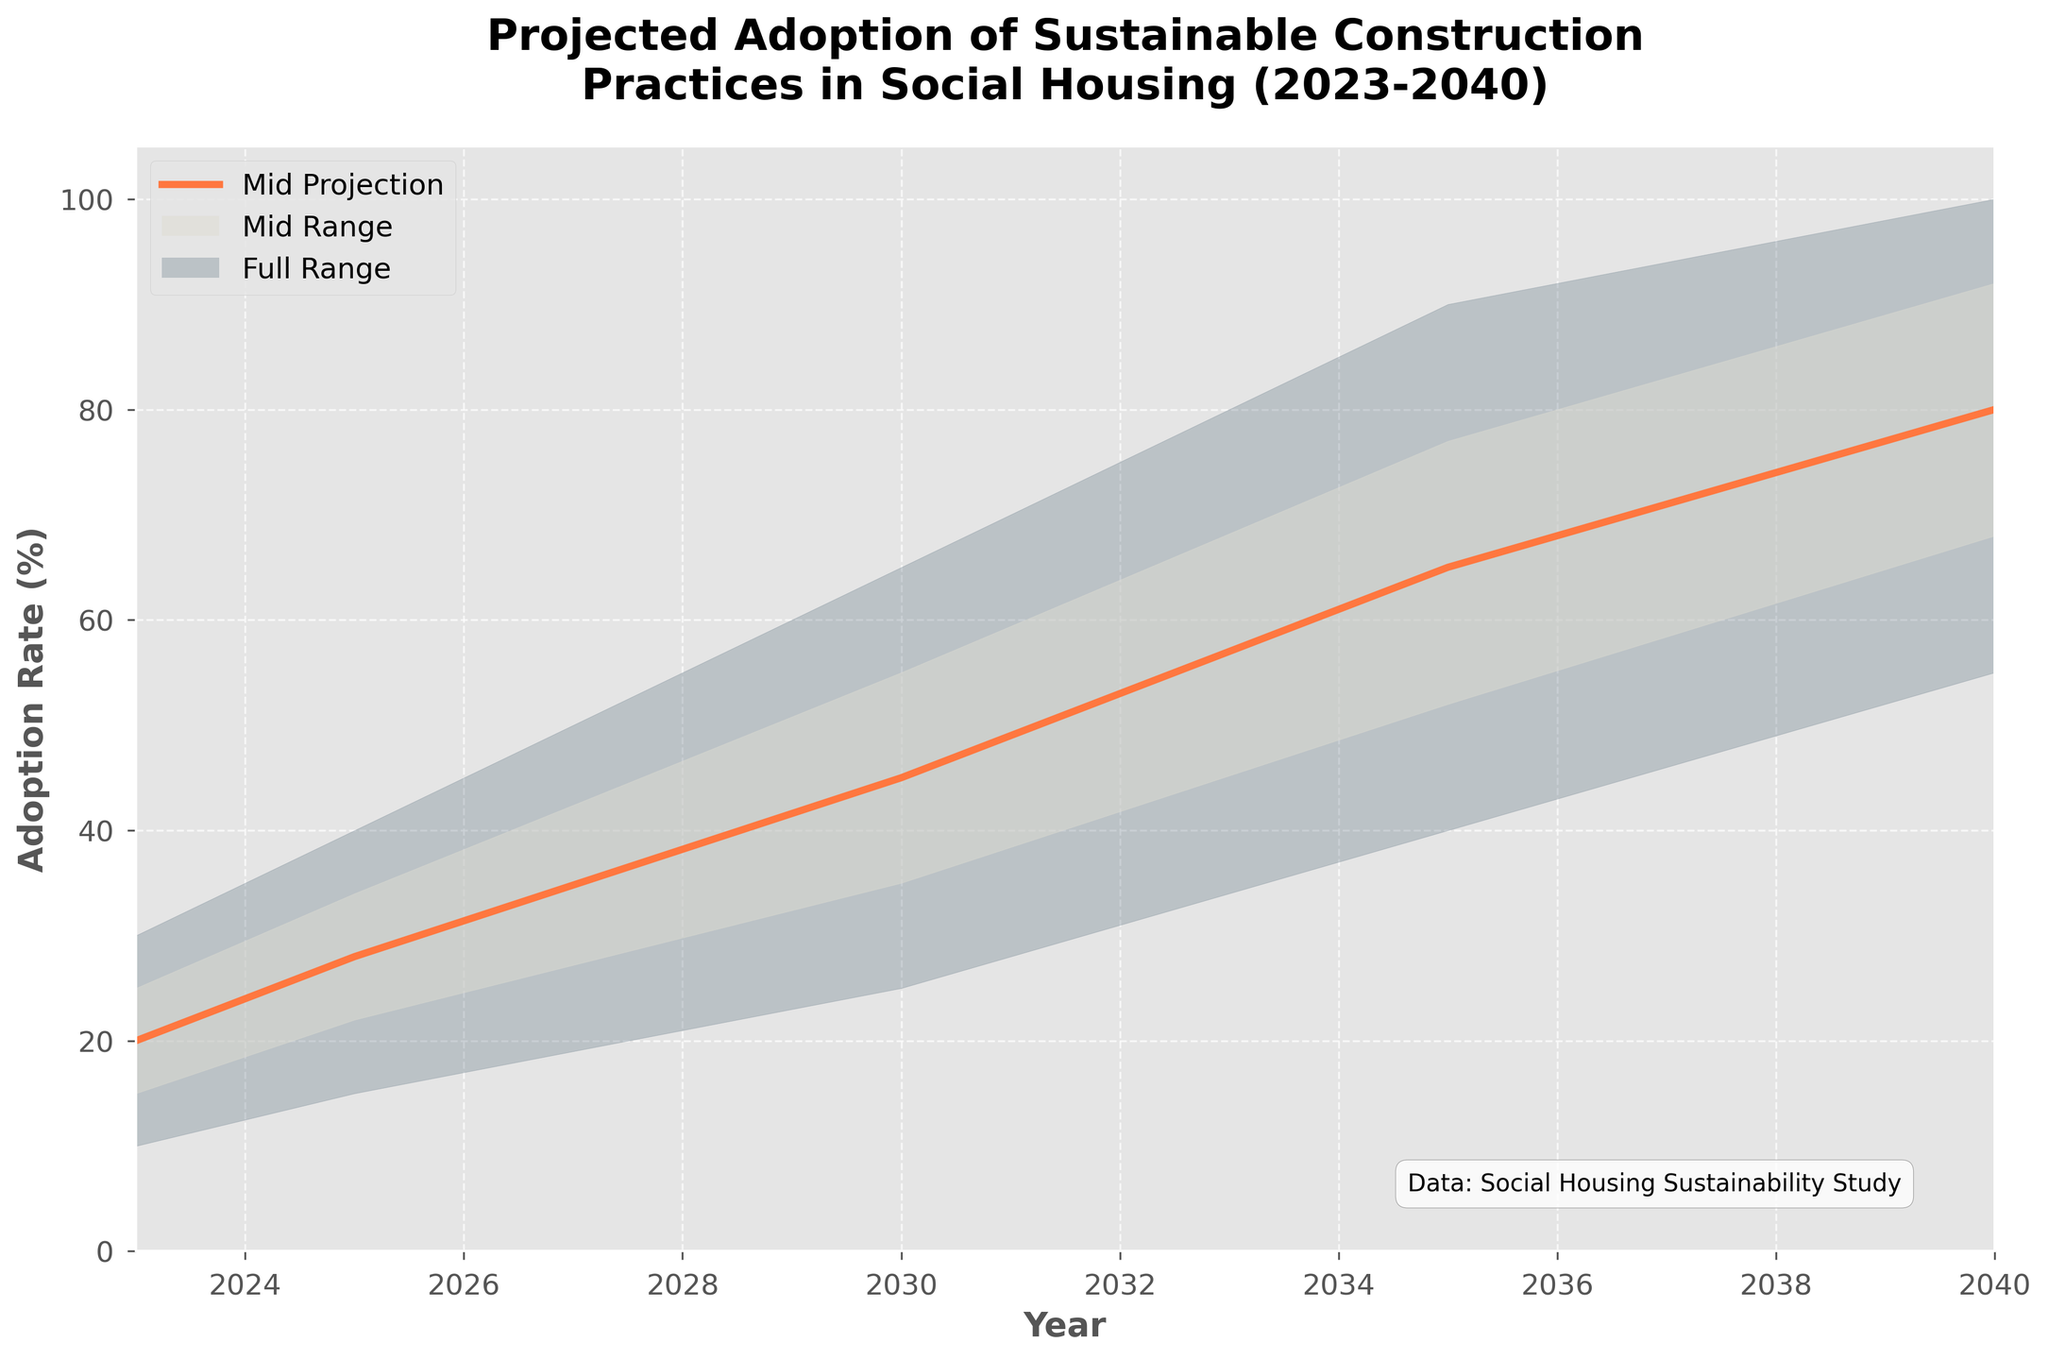What's the title of the chart? The title of the chart is located at the top and in bold. It reads, "Projected Adoption of Sustainable Construction Practices in Social Housing (2023-2040)."
Answer: Projected Adoption of Sustainable Construction Practices in Social Housing (2023-2040) What does the "Mid Projection" line represent? The "Mid Projection" line is the thick line on the chart that represents the midpoint of the projected adoption rates. It's plotted across the years and shows the expected rate of adoption under normal circumstances.
Answer: The midpoint of projected adoption rates What range of adoption rates is projected for the year 2030? To find the range of adoption rates for 2030, look at the filled areas in the chart for that year. The low and high values for 2030 are 25% and 65%, respectively, indicating that the adoption rate could be anywhere within this range.
Answer: 25% to 65% Which year shows the highest potential adoption rate according to the projections? By examining the "High" section of the chart, the year 2040 has the highest potential adoption rate at 100%.
Answer: 2040 How does the predicted adoption rate in 2025 compare to 2023? To compare the adoption rates in 2025 and 2023, check the "Mid" projection line. In 2023, the "Mid" value is 20%, and in 2025, it is 28%. Thus, the rate is higher in 2025.
Answer: Higher in 2025 What are the five percentile lines used in the chart? The five lines in the chart are the projections labeled as Low, Low-Mid, Mid, Mid-High, and High. These represent different scenarios of future adoption rates.
Answer: Low, Low-Mid, Mid, Mid-High, High What is the projected increase in the mid adoption rate from 2023 to 2040? Refer to the "Mid" projection for both years: 20% in 2023 and 80% in 2040. The increase is calculated as 80% - 20% = 60%.
Answer: 60% Between which years is the most significant increase in the mid adoption rate observed? Comparing the increments between consecutive years, the most significant increase appears between 2025 (28%) and 2030 (45%). The increase is 17%.
Answer: Between 2025 and 2030 Which year has the narrowest range of projected adoption rates, and what is that range? The narrowest range is determined by calculating the difference between the High and Low projections. For 2023, the range is 30% - 10% = 20%. For 2025, it's 40% - 15% = 25%. For 2030, it's 65% - 25% = 40%. For 2035, it's 90% - 40% = 50%. For 2040, it's 100% - 55% = 45%. The narrowest range is in 2023, with a 20% difference.
Answer: 2023, 20% What does the shaded area between the "Low" and "High" projections indicate? The shaded area between the "Low" and "High" projections represents the full range of possible adoption rates, showing the uncertainty and variation in the projections. It spans from the minimum to the maximum projected values for each year.
Answer: Full range of possible adoption rates 